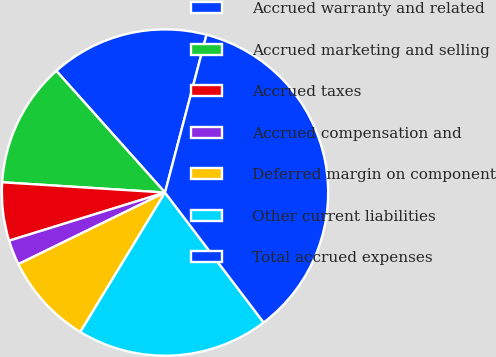Convert chart to OTSL. <chart><loc_0><loc_0><loc_500><loc_500><pie_chart><fcel>Accrued warranty and related<fcel>Accrued marketing and selling<fcel>Accrued taxes<fcel>Accrued compensation and<fcel>Deferred margin on component<fcel>Other current liabilities<fcel>Total accrued expenses<nl><fcel>15.7%<fcel>12.39%<fcel>5.77%<fcel>2.46%<fcel>9.08%<fcel>19.02%<fcel>35.57%<nl></chart> 